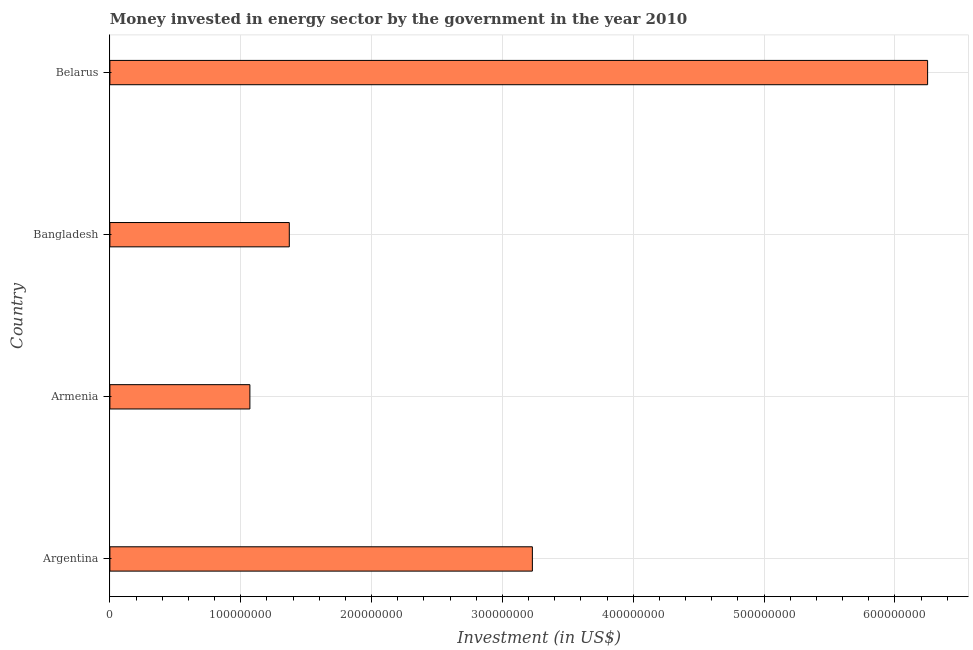Does the graph contain any zero values?
Provide a short and direct response. No. What is the title of the graph?
Provide a succinct answer. Money invested in energy sector by the government in the year 2010. What is the label or title of the X-axis?
Keep it short and to the point. Investment (in US$). What is the label or title of the Y-axis?
Provide a succinct answer. Country. What is the investment in energy in Armenia?
Give a very brief answer. 1.07e+08. Across all countries, what is the maximum investment in energy?
Ensure brevity in your answer.  6.25e+08. Across all countries, what is the minimum investment in energy?
Your answer should be compact. 1.07e+08. In which country was the investment in energy maximum?
Give a very brief answer. Belarus. In which country was the investment in energy minimum?
Provide a short and direct response. Armenia. What is the sum of the investment in energy?
Your answer should be very brief. 1.19e+09. What is the difference between the investment in energy in Armenia and Belarus?
Offer a very short reply. -5.18e+08. What is the average investment in energy per country?
Your response must be concise. 2.98e+08. What is the median investment in energy?
Your answer should be compact. 2.30e+08. In how many countries, is the investment in energy greater than 160000000 US$?
Provide a short and direct response. 2. What is the ratio of the investment in energy in Argentina to that in Belarus?
Keep it short and to the point. 0.52. Is the investment in energy in Armenia less than that in Bangladesh?
Provide a succinct answer. Yes. What is the difference between the highest and the second highest investment in energy?
Provide a short and direct response. 3.02e+08. What is the difference between the highest and the lowest investment in energy?
Make the answer very short. 5.18e+08. How many bars are there?
Offer a very short reply. 4. What is the difference between two consecutive major ticks on the X-axis?
Provide a short and direct response. 1.00e+08. Are the values on the major ticks of X-axis written in scientific E-notation?
Provide a succinct answer. No. What is the Investment (in US$) in Argentina?
Provide a succinct answer. 3.23e+08. What is the Investment (in US$) of Armenia?
Provide a succinct answer. 1.07e+08. What is the Investment (in US$) in Bangladesh?
Ensure brevity in your answer.  1.37e+08. What is the Investment (in US$) of Belarus?
Make the answer very short. 6.25e+08. What is the difference between the Investment (in US$) in Argentina and Armenia?
Your response must be concise. 2.16e+08. What is the difference between the Investment (in US$) in Argentina and Bangladesh?
Keep it short and to the point. 1.86e+08. What is the difference between the Investment (in US$) in Argentina and Belarus?
Provide a succinct answer. -3.02e+08. What is the difference between the Investment (in US$) in Armenia and Bangladesh?
Your response must be concise. -3.01e+07. What is the difference between the Investment (in US$) in Armenia and Belarus?
Keep it short and to the point. -5.18e+08. What is the difference between the Investment (in US$) in Bangladesh and Belarus?
Make the answer very short. -4.88e+08. What is the ratio of the Investment (in US$) in Argentina to that in Armenia?
Offer a terse response. 3.02. What is the ratio of the Investment (in US$) in Argentina to that in Bangladesh?
Provide a short and direct response. 2.35. What is the ratio of the Investment (in US$) in Argentina to that in Belarus?
Provide a succinct answer. 0.52. What is the ratio of the Investment (in US$) in Armenia to that in Bangladesh?
Give a very brief answer. 0.78. What is the ratio of the Investment (in US$) in Armenia to that in Belarus?
Provide a succinct answer. 0.17. What is the ratio of the Investment (in US$) in Bangladesh to that in Belarus?
Provide a succinct answer. 0.22. 